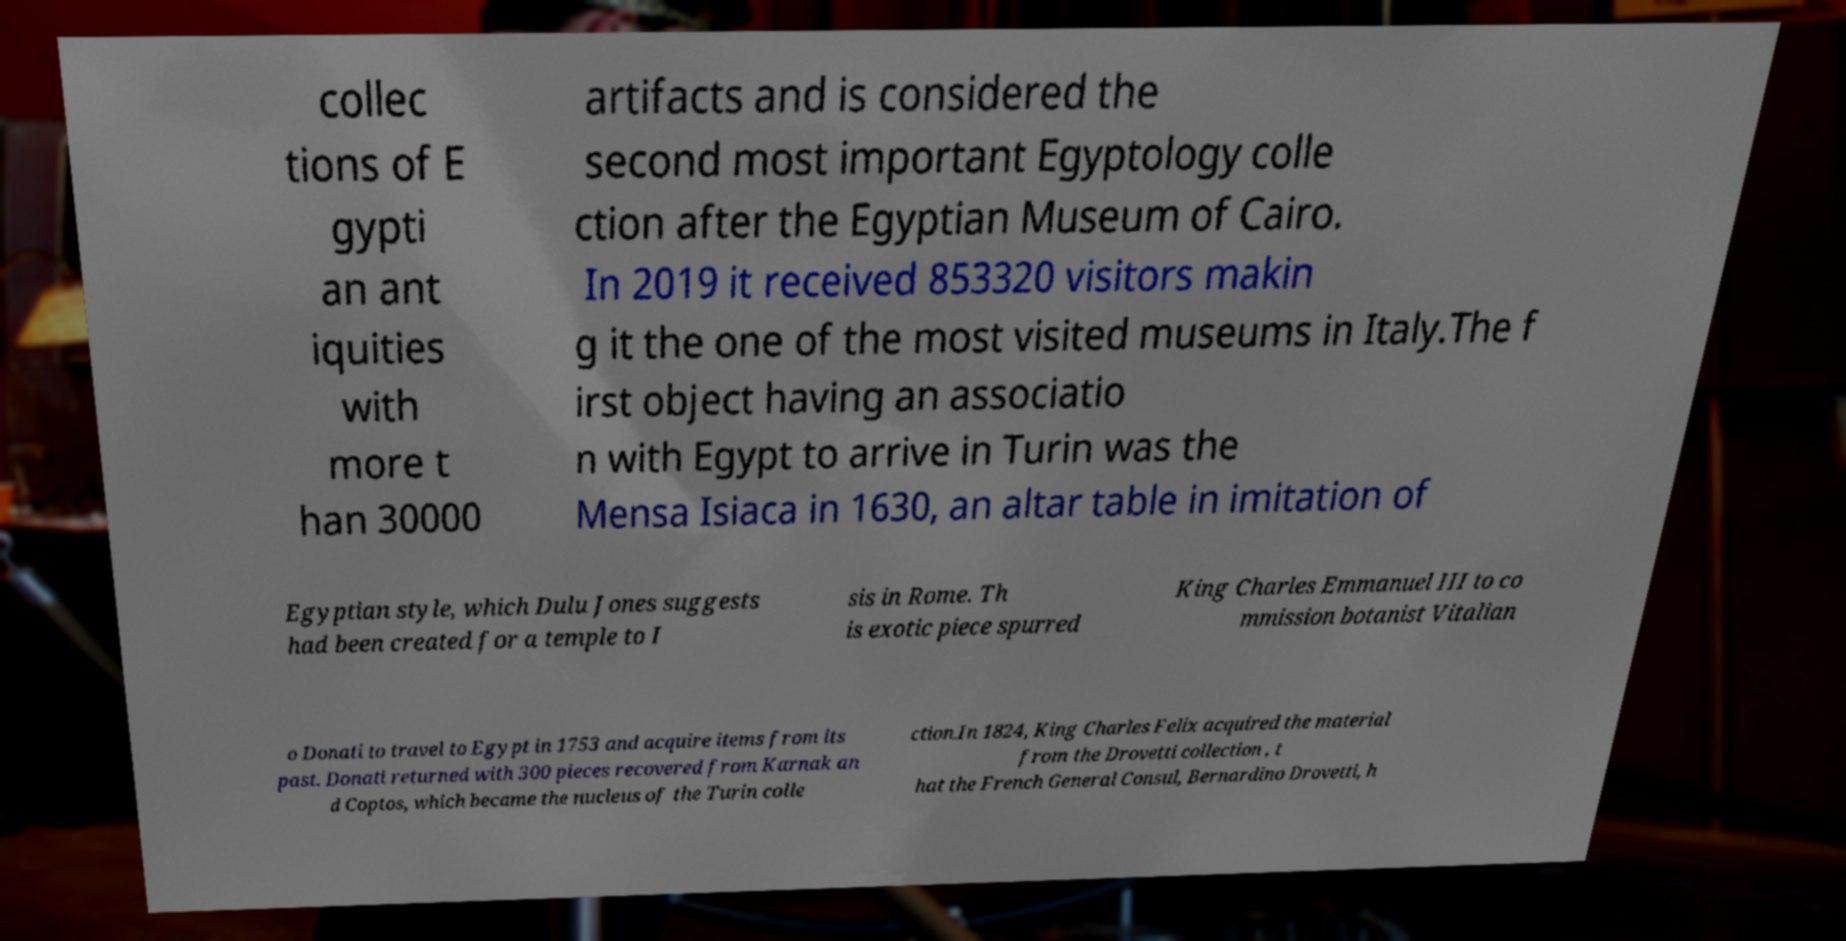Please read and relay the text visible in this image. What does it say? collec tions of E gypti an ant iquities with more t han 30000 artifacts and is considered the second most important Egyptology colle ction after the Egyptian Museum of Cairo. In 2019 it received 853320 visitors makin g it the one of the most visited museums in Italy.The f irst object having an associatio n with Egypt to arrive in Turin was the Mensa Isiaca in 1630, an altar table in imitation of Egyptian style, which Dulu Jones suggests had been created for a temple to I sis in Rome. Th is exotic piece spurred King Charles Emmanuel III to co mmission botanist Vitalian o Donati to travel to Egypt in 1753 and acquire items from its past. Donati returned with 300 pieces recovered from Karnak an d Coptos, which became the nucleus of the Turin colle ction.In 1824, King Charles Felix acquired the material from the Drovetti collection , t hat the French General Consul, Bernardino Drovetti, h 